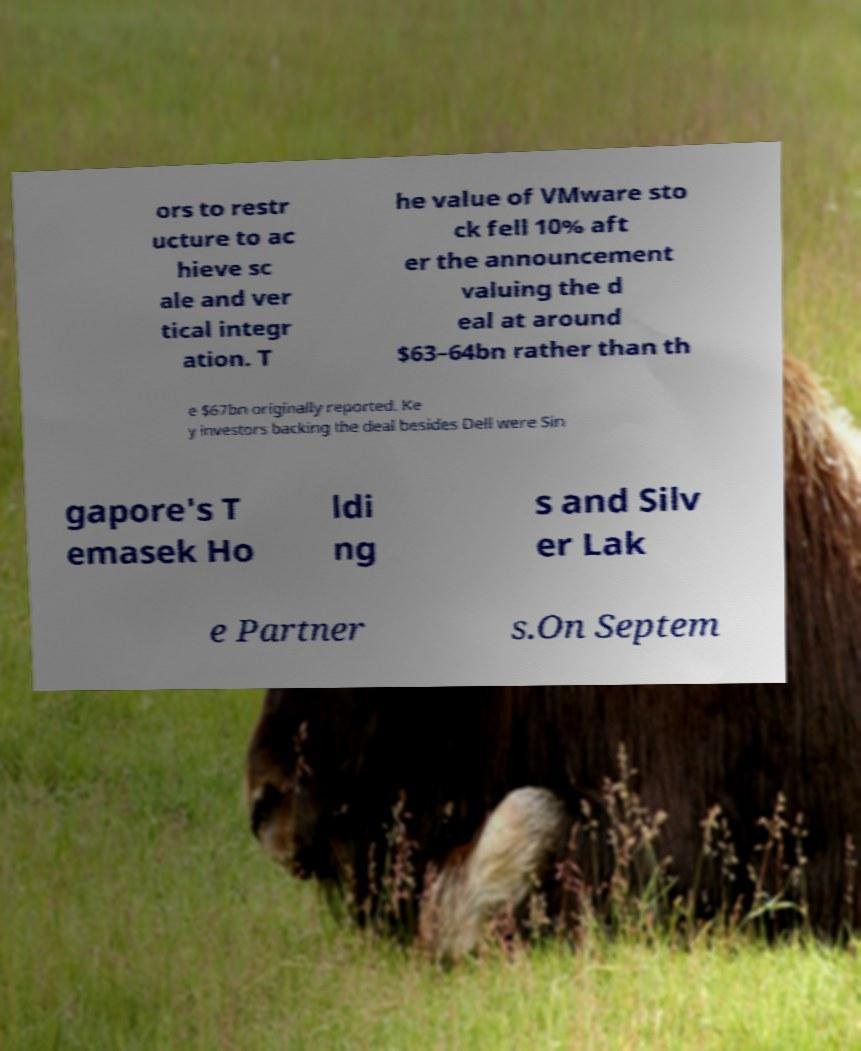For documentation purposes, I need the text within this image transcribed. Could you provide that? ors to restr ucture to ac hieve sc ale and ver tical integr ation. T he value of VMware sto ck fell 10% aft er the announcement valuing the d eal at around $63–64bn rather than th e $67bn originally reported. Ke y investors backing the deal besides Dell were Sin gapore's T emasek Ho ldi ng s and Silv er Lak e Partner s.On Septem 